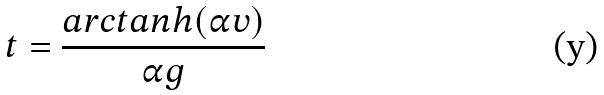Convert formula to latex. <formula><loc_0><loc_0><loc_500><loc_500>t = \frac { a r c t a n h ( \alpha v ) } { \alpha g }</formula> 